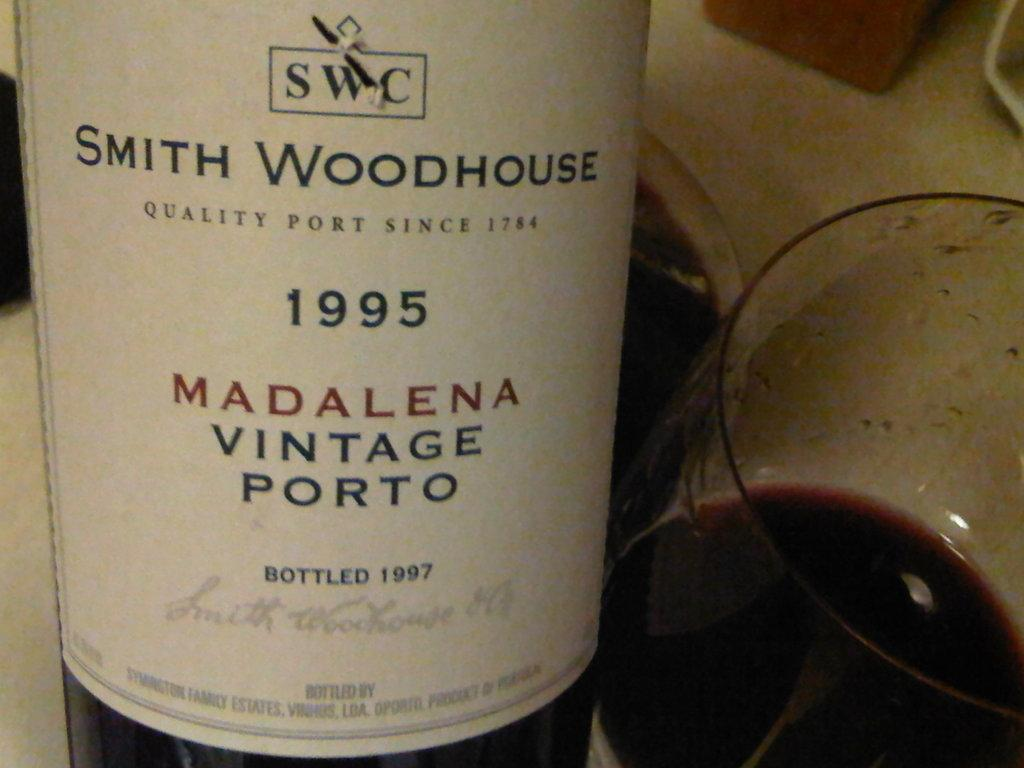<image>
Share a concise interpretation of the image provided. The white label for Smith Woodhouse vintage port from 1995. 